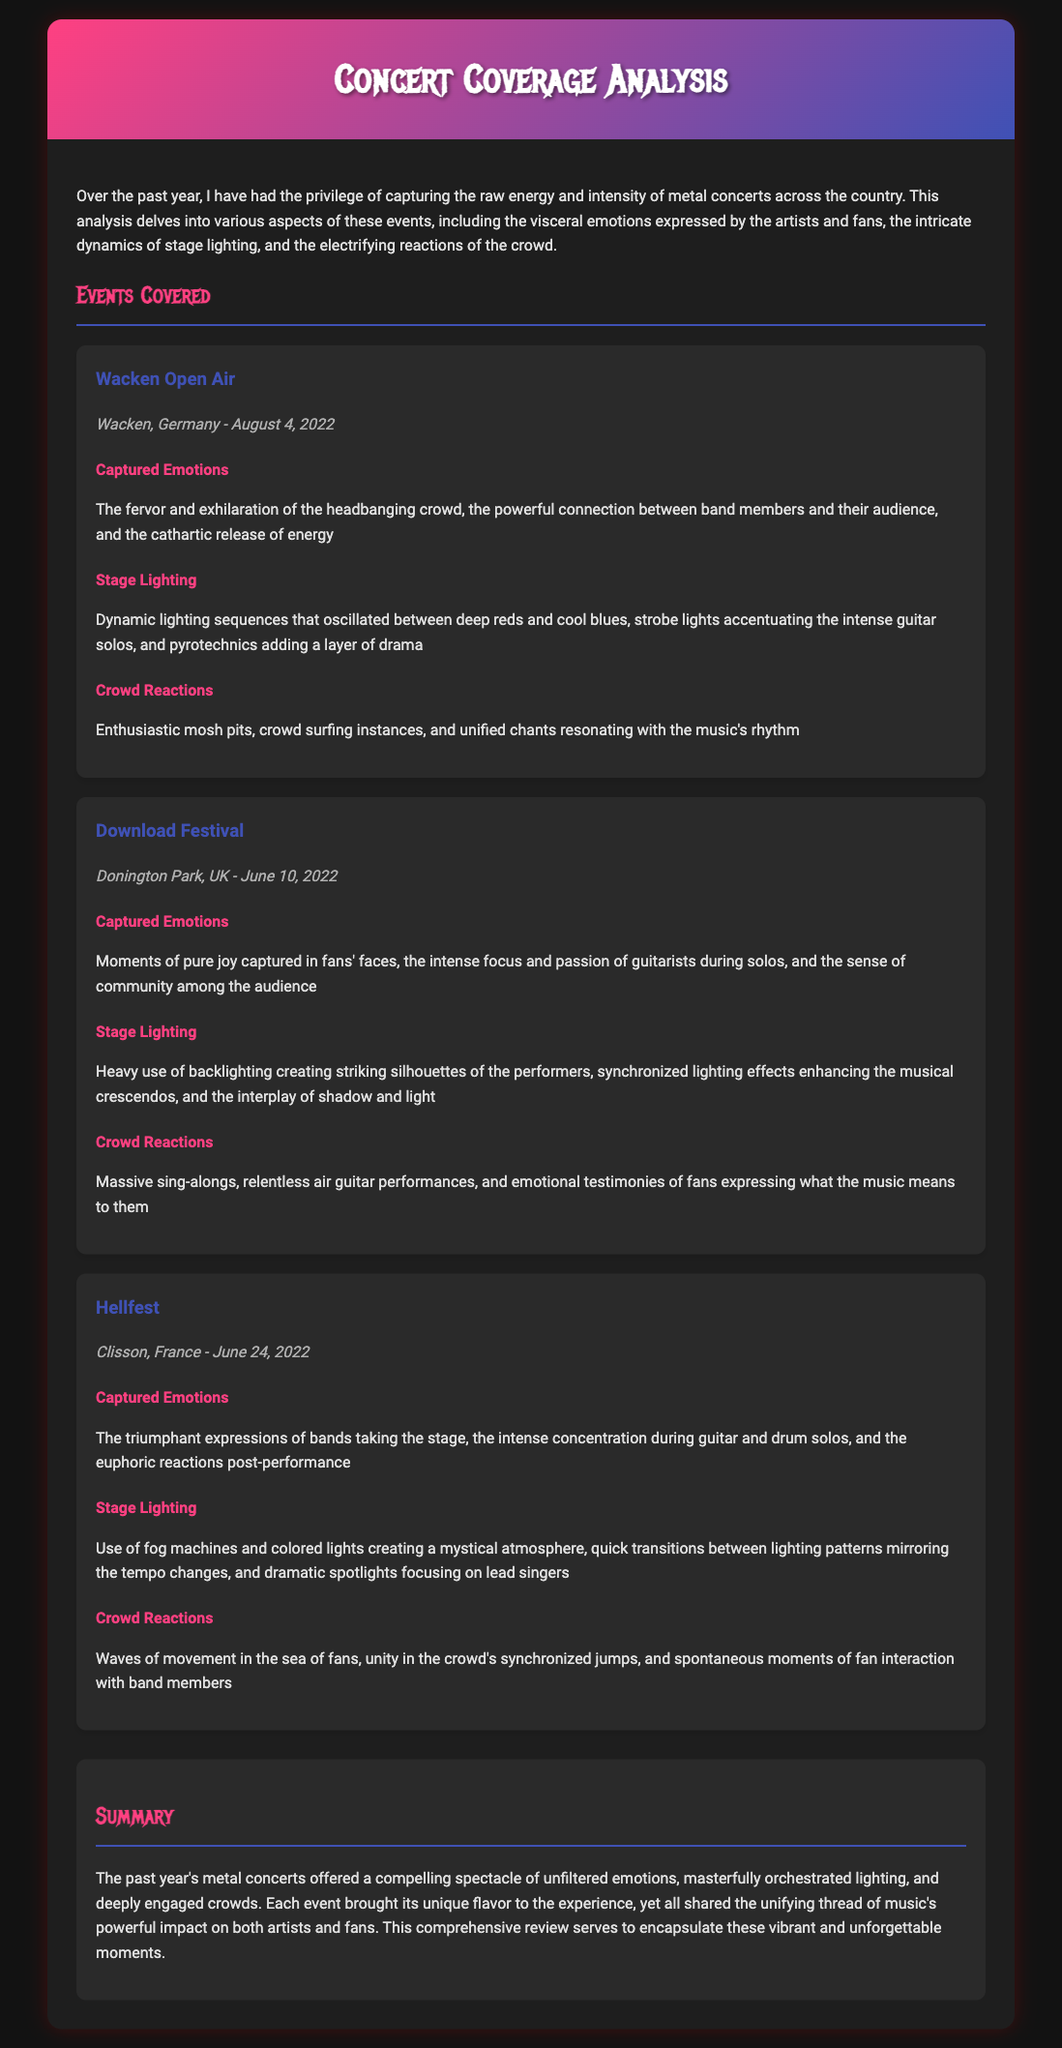What is the title of the document? The title of the document is found in the header section of the webpage.
Answer: Concert Coverage Analysis How many events are covered in the document? By counting the events listed under "Events Covered," we find a total of three events.
Answer: 3 What emotion was highlighted at Wacken Open Air? The specific emotion highlighted in the event's section is detailed under "Captured Emotions."
Answer: exhilaration What stage lighting technique was used at Download Festival? The document describes the lighting techniques under the "Stage Lighting" section for each event.
Answer: backlighting What was the date of the Hellfest event? The date for the Hellfest event is mentioned in the event details section.
Answer: June 24, 2022 What type of crowd reaction was noted for Wacken Open Air? The document lists specific crowd reactions under each event's "Crowd Reactions" section.
Answer: mosh pits What is the main theme of the summary section? The summary section encapsulates the overall experience and emotions throughout the events covered.
Answer: unfiltered emotions Which festival took place in France? The document explicitly identifies the event that occurred in France.
Answer: Hellfest What was a notable crowd interaction at Hellfest? Specific crowd interactions are detailed under the "Crowd Reactions" section for each event.
Answer: spontaneous moments 